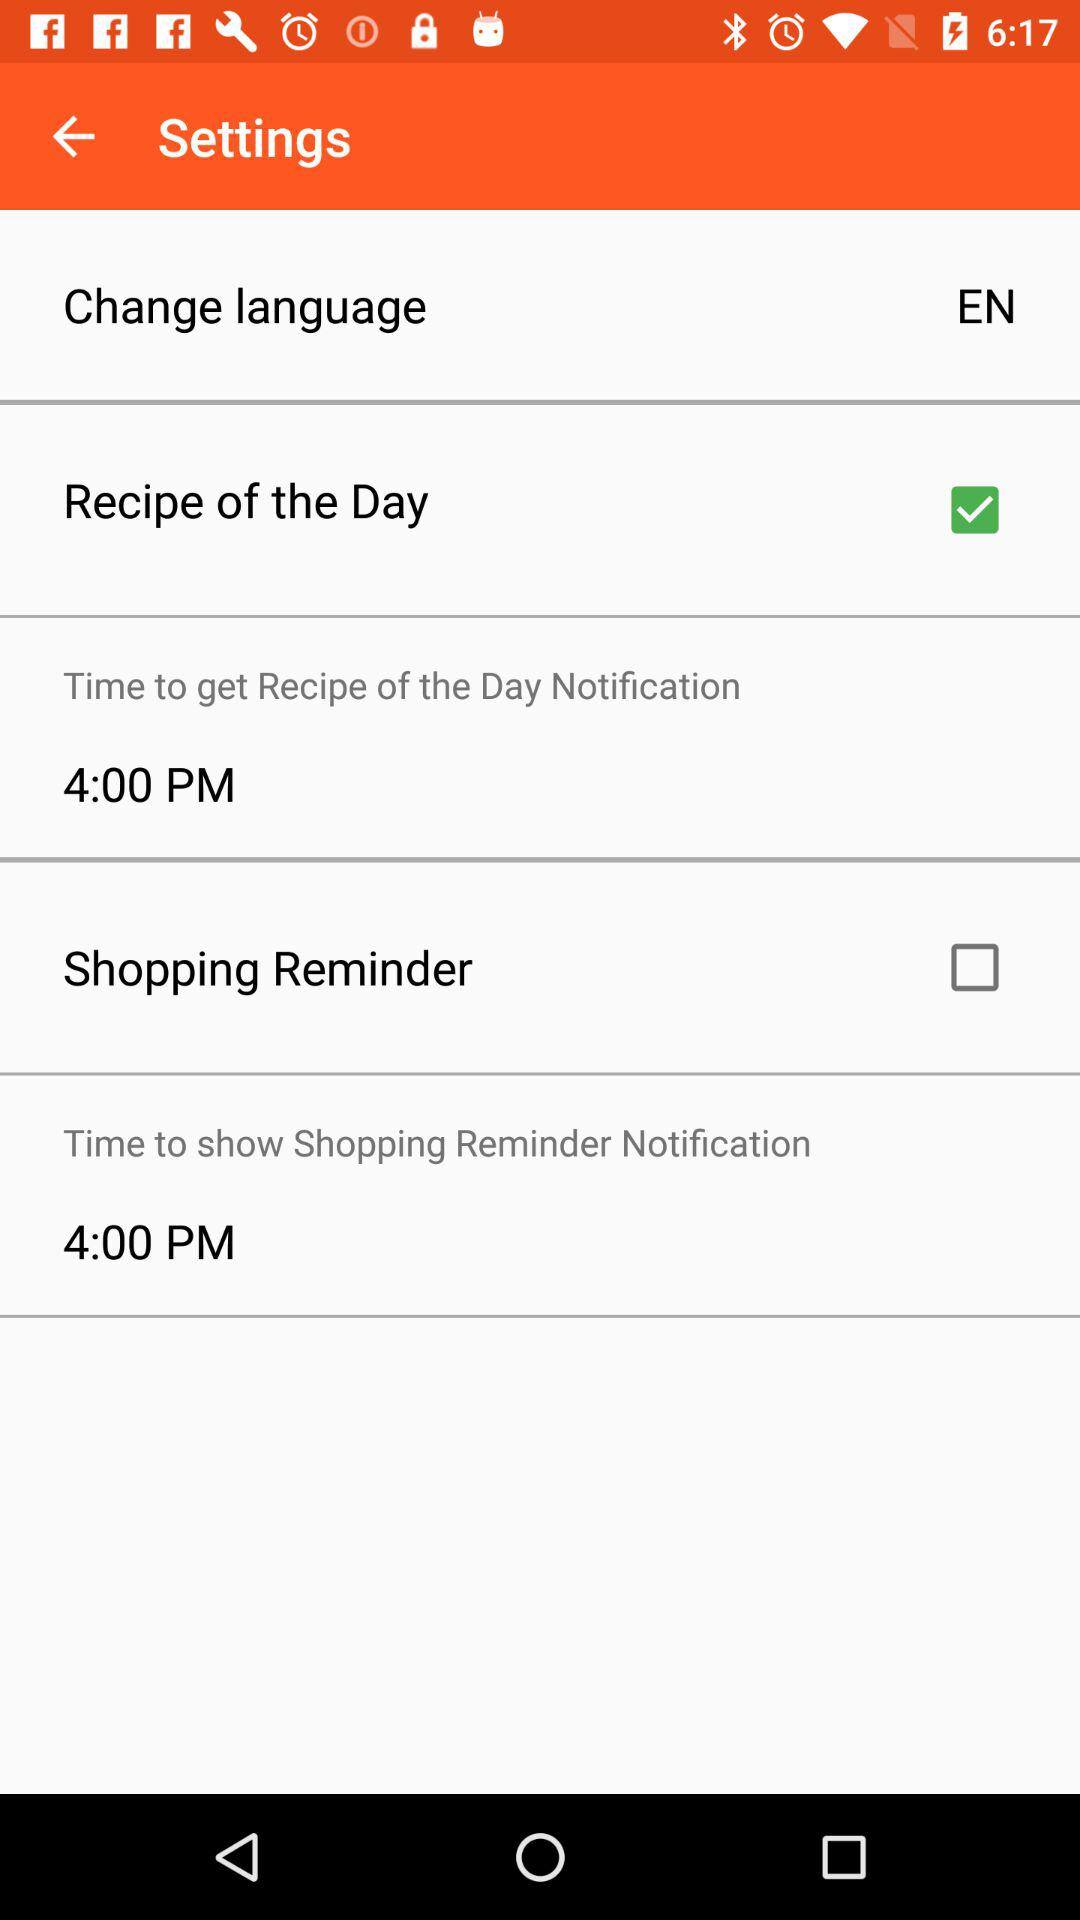Which is the selected language? The selected language is "EN". 